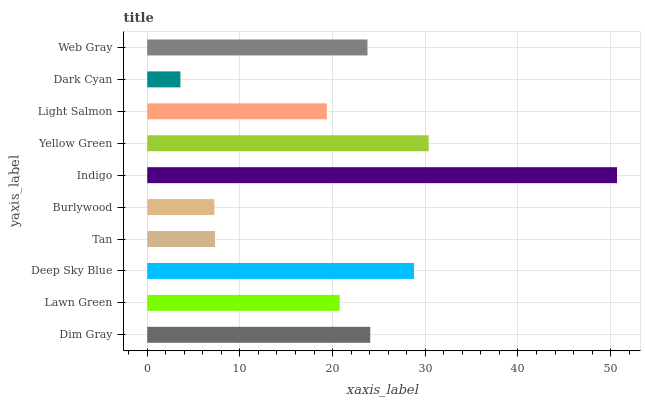Is Dark Cyan the minimum?
Answer yes or no. Yes. Is Indigo the maximum?
Answer yes or no. Yes. Is Lawn Green the minimum?
Answer yes or no. No. Is Lawn Green the maximum?
Answer yes or no. No. Is Dim Gray greater than Lawn Green?
Answer yes or no. Yes. Is Lawn Green less than Dim Gray?
Answer yes or no. Yes. Is Lawn Green greater than Dim Gray?
Answer yes or no. No. Is Dim Gray less than Lawn Green?
Answer yes or no. No. Is Web Gray the high median?
Answer yes or no. Yes. Is Lawn Green the low median?
Answer yes or no. Yes. Is Lawn Green the high median?
Answer yes or no. No. Is Web Gray the low median?
Answer yes or no. No. 